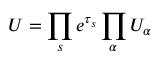<formula> <loc_0><loc_0><loc_500><loc_500>U = \prod _ { s } e ^ { \tau _ { s } } \prod _ { \alpha } U _ { \alpha }</formula> 